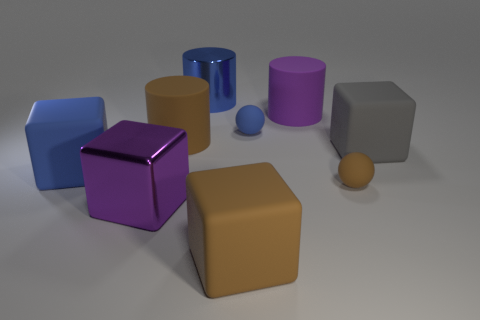Subtract all cylinders. How many objects are left? 6 Subtract all big brown objects. Subtract all large cylinders. How many objects are left? 4 Add 5 cylinders. How many cylinders are left? 8 Add 5 large yellow metallic things. How many large yellow metallic things exist? 5 Subtract 0 green blocks. How many objects are left? 9 